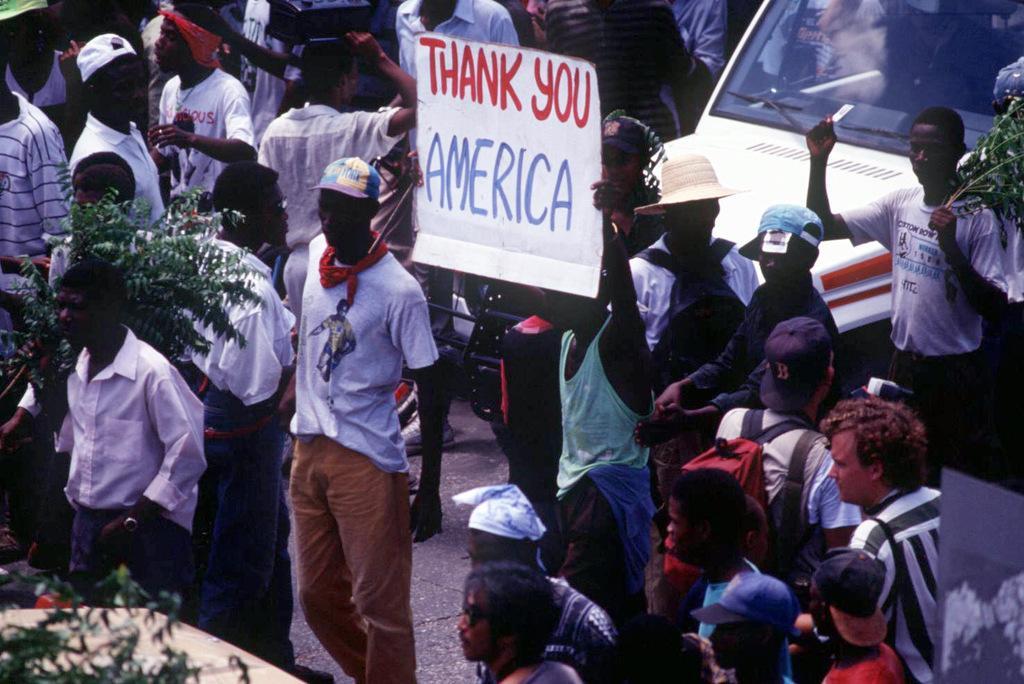How would you summarize this image in a sentence or two? Here we can see group of people and they are holding a board with their hands. And there is a vehicle. 